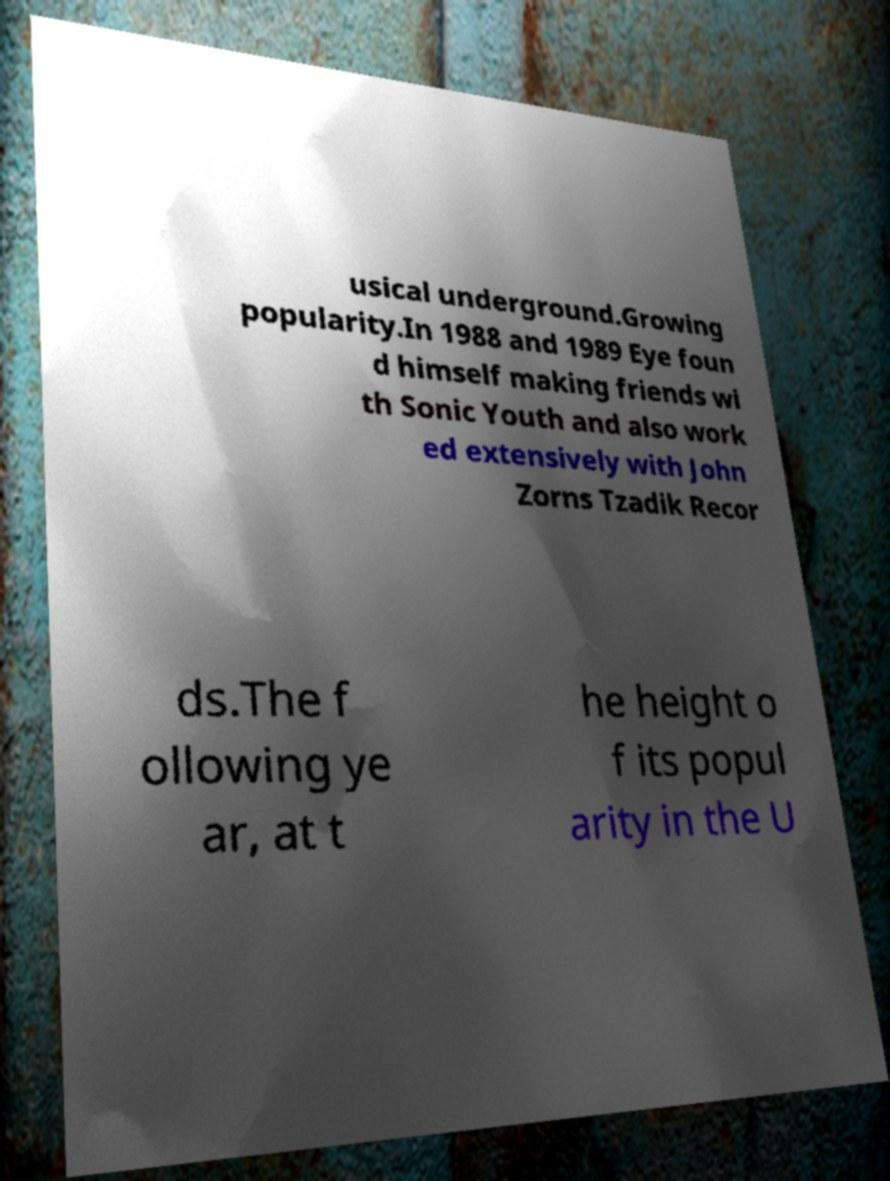Could you extract and type out the text from this image? usical underground.Growing popularity.In 1988 and 1989 Eye foun d himself making friends wi th Sonic Youth and also work ed extensively with John Zorns Tzadik Recor ds.The f ollowing ye ar, at t he height o f its popul arity in the U 